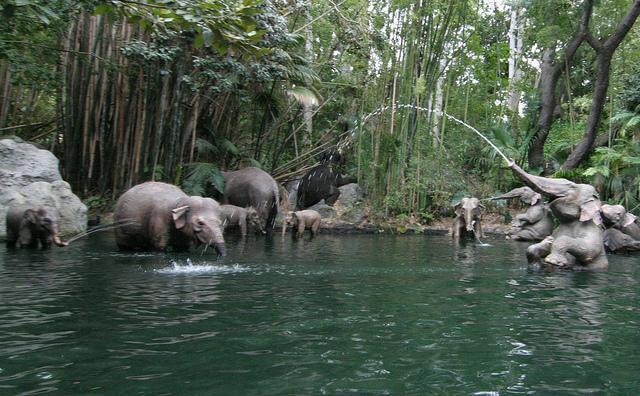How many elephants are there?
Give a very brief answer. 5. 